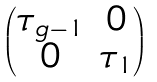Convert formula to latex. <formula><loc_0><loc_0><loc_500><loc_500>\begin{pmatrix} \tau _ { g - 1 } & 0 \\ 0 & \tau _ { 1 } \end{pmatrix}</formula> 